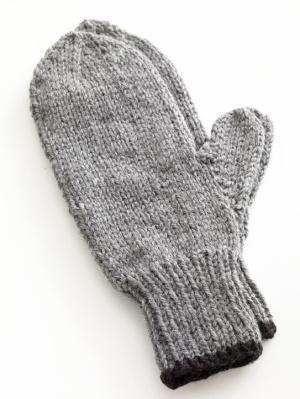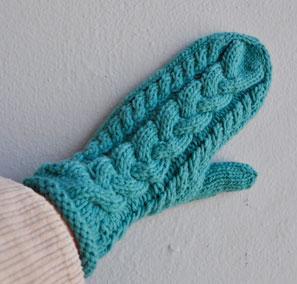The first image is the image on the left, the second image is the image on the right. Considering the images on both sides, is "More than half of a mitten is covered by another mitten." valid? Answer yes or no. Yes. 